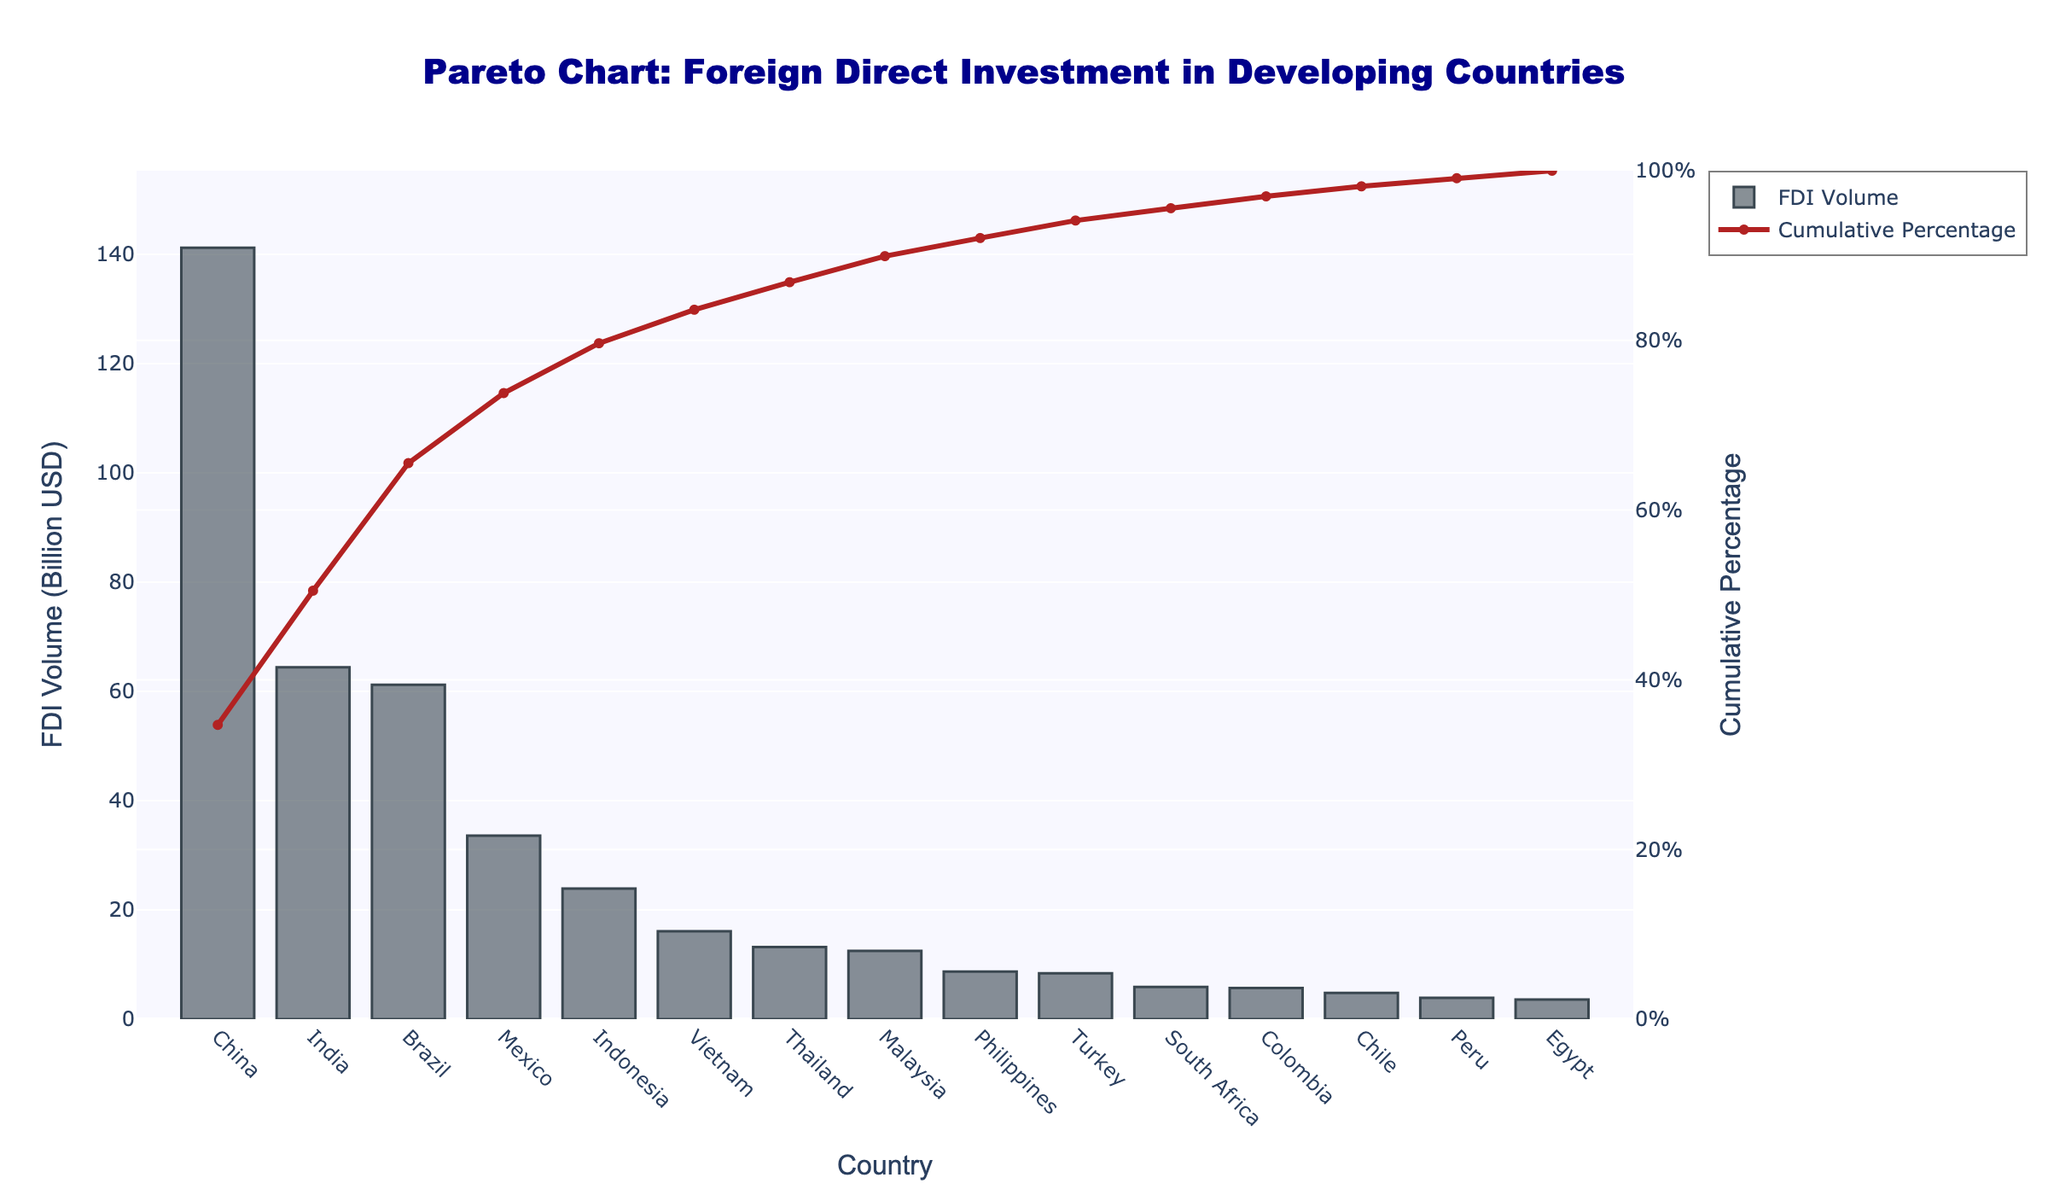Which country has the highest volume of foreign direct investment? The country with the tallest bar on the left of the chart represents the highest volume of FDI.
Answer: China What is the title of the chart? The title is displayed at the top center of the chart.
Answer: Pareto Chart: Foreign Direct Investment in Developing Countries How many countries have their FDI volume labeled in the chart? Count the number of bars along the x-axis, each representing a country.
Answer: 15 What is the cumulative percentage of FDI volume after the first three countries? Sum the cumulative percentages for the top three countries (China, India, and Brazil) on the red line.
Answer: Approximately 60.4% What percentage of the total FDI volume is contributed by India alone? Identify India's bar on the x-axis, refer to the height of the bar, and compare it to the others, particularly using the accompanying cumulative percentage shift if necessary.
Answer: Approximately 18.0% Which country has a lower FDI volume: Vietnam or Malaysia? Compare the heights of the bars for Vietnam and Malaysia.
Answer: Malaysia Which country marks the point where the cumulative percentage exceeds 90%? Identify the country on the x-axis where the red cumulative percentage line first crosses above 90% toward 100%.
Answer: Philippines What is the FDI volume of Mexico? Identify the height of the bar corresponding to Mexico and look for the FDI volume in billion USD.
Answer: 33.6 billion USD What is the combined FDI volume of Thailand, Malaysia, and the Philippines? Sum the FDI volumes of Thailand, Malaysia, and the Philippines shown by the heights of their respective bars.
Answer: 32.3 billion USD Which country has the smallest volume of foreign direct investment, and what is its value? Identify the country with the shortest bar on the right end of the chart, and note its FDI volume.
Answer: Egypt, 3.6 billion USD 